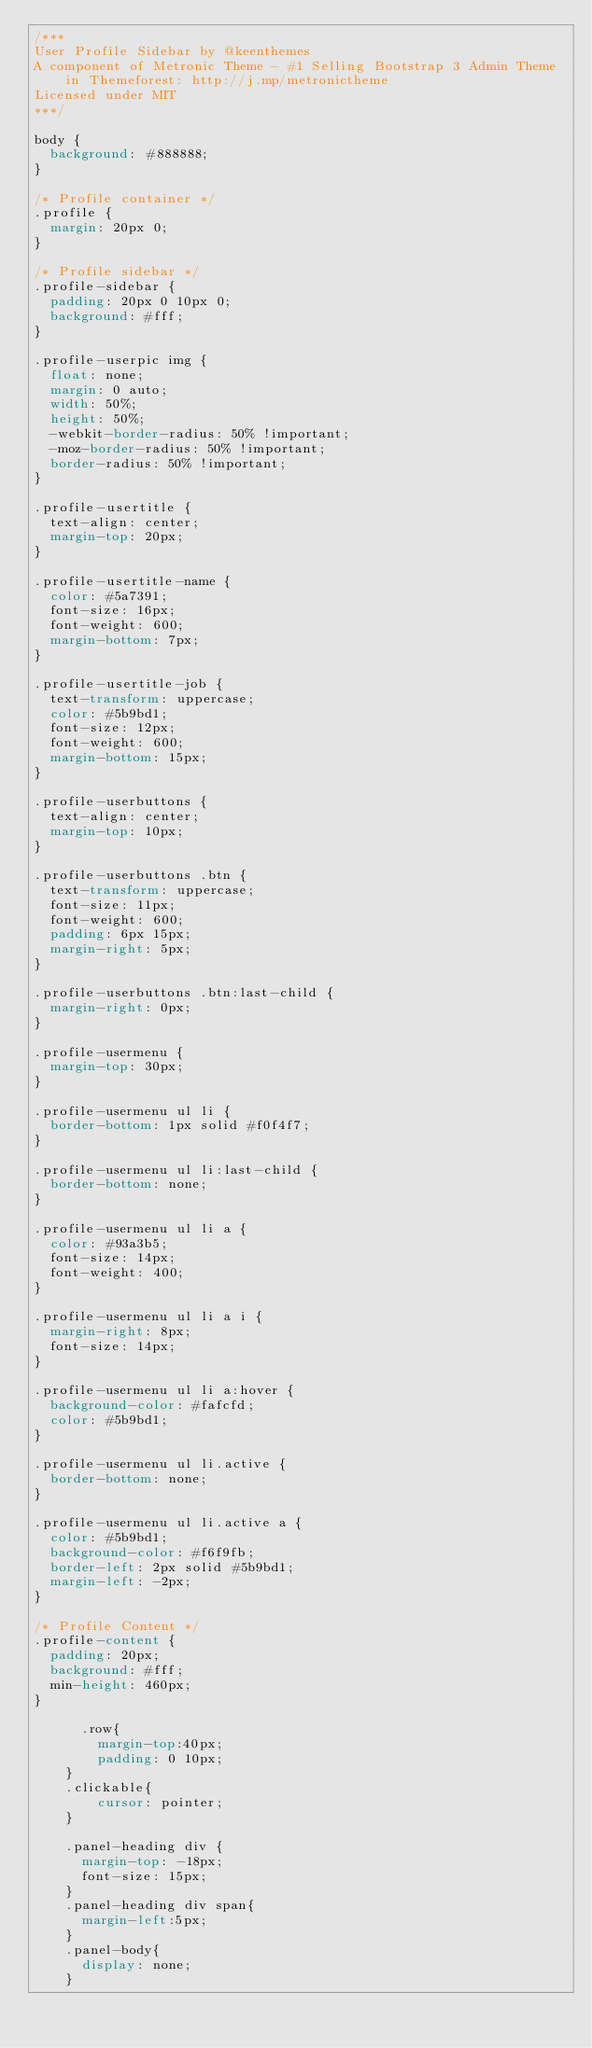Convert code to text. <code><loc_0><loc_0><loc_500><loc_500><_CSS_>/***
User Profile Sidebar by @keenthemes
A component of Metronic Theme - #1 Selling Bootstrap 3 Admin Theme in Themeforest: http://j.mp/metronictheme
Licensed under MIT
***/

body {
  background: #888888;
}

/* Profile container */
.profile {
  margin: 20px 0;
}

/* Profile sidebar */
.profile-sidebar {
  padding: 20px 0 10px 0;
  background: #fff;
}

.profile-userpic img {
  float: none;
  margin: 0 auto;
  width: 50%;
  height: 50%;
  -webkit-border-radius: 50% !important;
  -moz-border-radius: 50% !important;
  border-radius: 50% !important;
}

.profile-usertitle {
  text-align: center;
  margin-top: 20px;
}

.profile-usertitle-name {
  color: #5a7391;
  font-size: 16px;
  font-weight: 600;
  margin-bottom: 7px;
}

.profile-usertitle-job {
  text-transform: uppercase;
  color: #5b9bd1;
  font-size: 12px;
  font-weight: 600;
  margin-bottom: 15px;
}

.profile-userbuttons {
  text-align: center;
  margin-top: 10px;
}

.profile-userbuttons .btn {
  text-transform: uppercase;
  font-size: 11px;
  font-weight: 600;
  padding: 6px 15px;
  margin-right: 5px;
}

.profile-userbuttons .btn:last-child {
  margin-right: 0px;
}
    
.profile-usermenu {
  margin-top: 30px;
}

.profile-usermenu ul li {
  border-bottom: 1px solid #f0f4f7;
}

.profile-usermenu ul li:last-child {
  border-bottom: none;
}

.profile-usermenu ul li a {
  color: #93a3b5;
  font-size: 14px;
  font-weight: 400;
}

.profile-usermenu ul li a i {
  margin-right: 8px;
  font-size: 14px;
}

.profile-usermenu ul li a:hover {
  background-color: #fafcfd;
  color: #5b9bd1;
}

.profile-usermenu ul li.active {
  border-bottom: none;
}

.profile-usermenu ul li.active a {
  color: #5b9bd1;
  background-color: #f6f9fb;
  border-left: 2px solid #5b9bd1;
  margin-left: -2px;
}

/* Profile Content */
.profile-content {
  padding: 20px;
  background: #fff;
  min-height: 460px;
}

      .row{
        margin-top:40px;
        padding: 0 10px;
    }
    .clickable{
        cursor: pointer;   
    }

    .panel-heading div {
      margin-top: -18px;
      font-size: 15px;
    }
    .panel-heading div span{
      margin-left:5px;
    }
    .panel-body{
      display: none;
    }</code> 